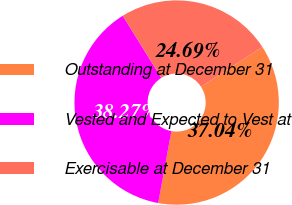Convert chart to OTSL. <chart><loc_0><loc_0><loc_500><loc_500><pie_chart><fcel>Outstanding at December 31<fcel>Vested and Expected to Vest at<fcel>Exercisable at December 31<nl><fcel>37.04%<fcel>38.27%<fcel>24.69%<nl></chart> 